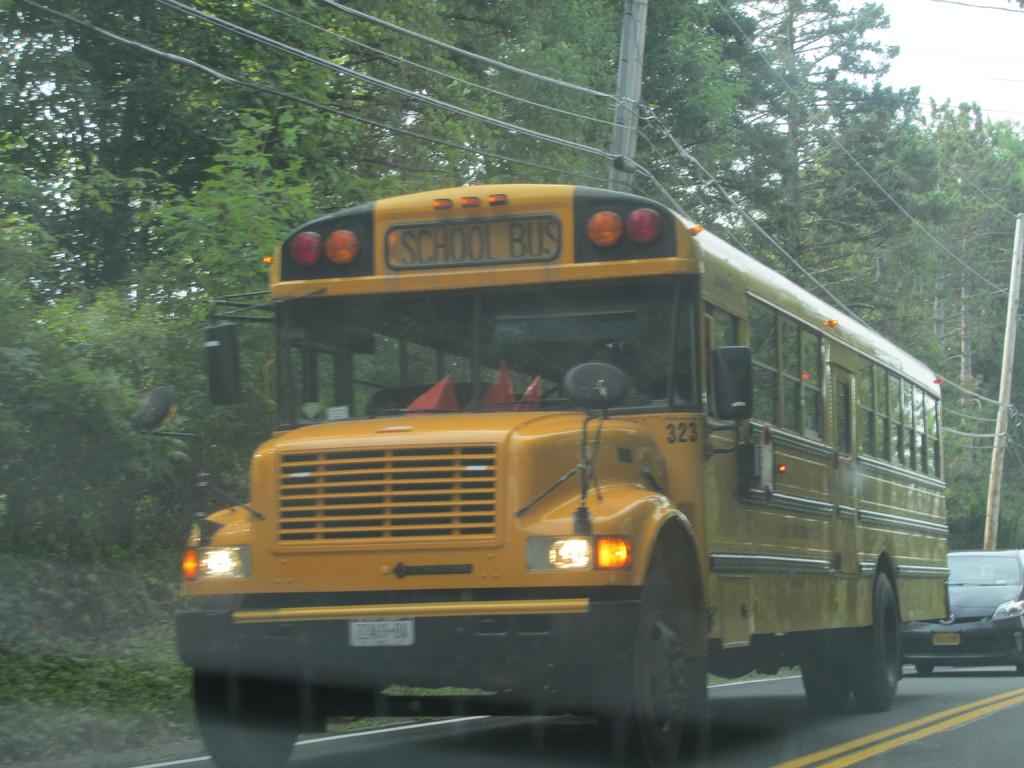<image>
Create a compact narrative representing the image presented. A yellow school bus is driving down a road with a car following behind it. 